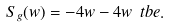Convert formula to latex. <formula><loc_0><loc_0><loc_500><loc_500>S _ { g } ( w ) = - 4 w - 4 w \ t b e .</formula> 